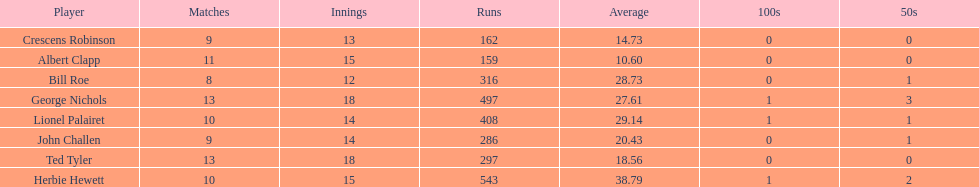Name a player that play in no more than 13 innings. Bill Roe. 